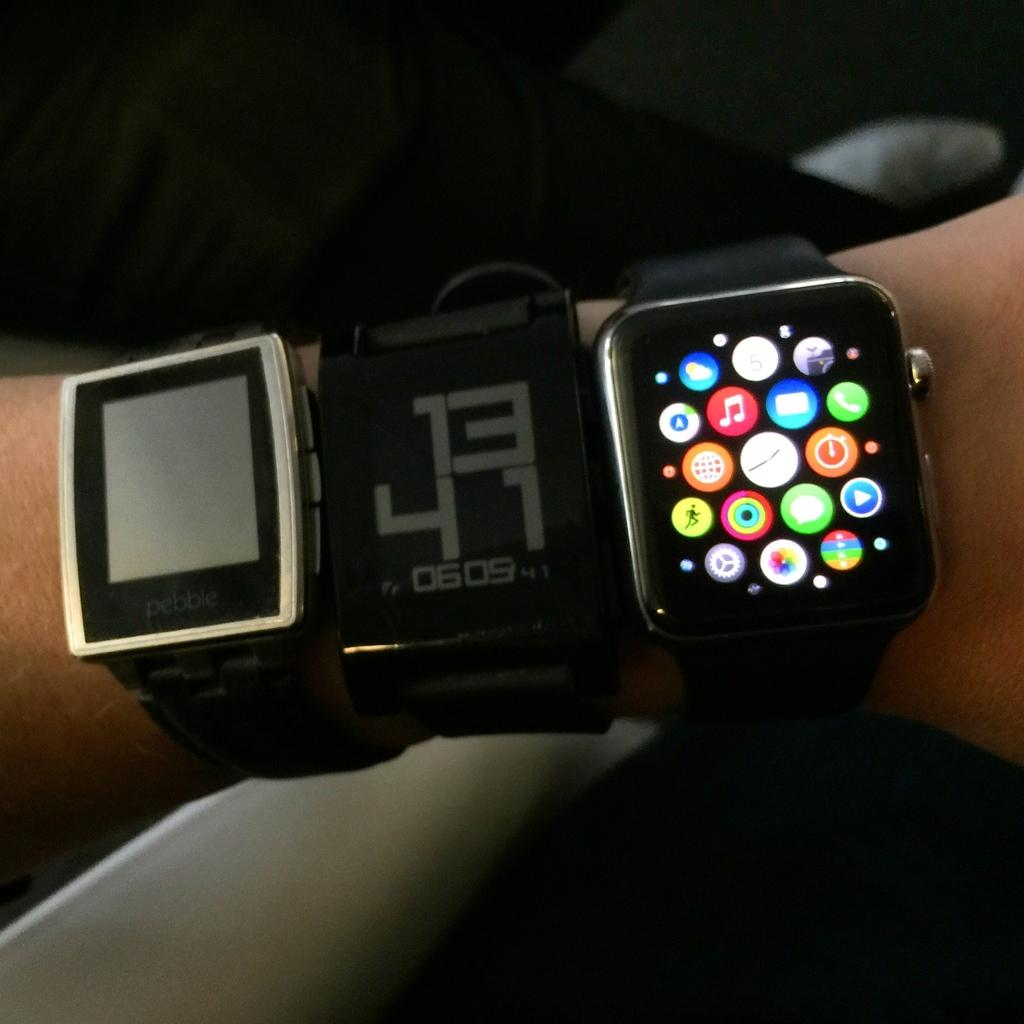<image>
Give a short and clear explanation of the subsequent image. Someone wears three smart watches, including one with the numbers 13 and 41 on it. 